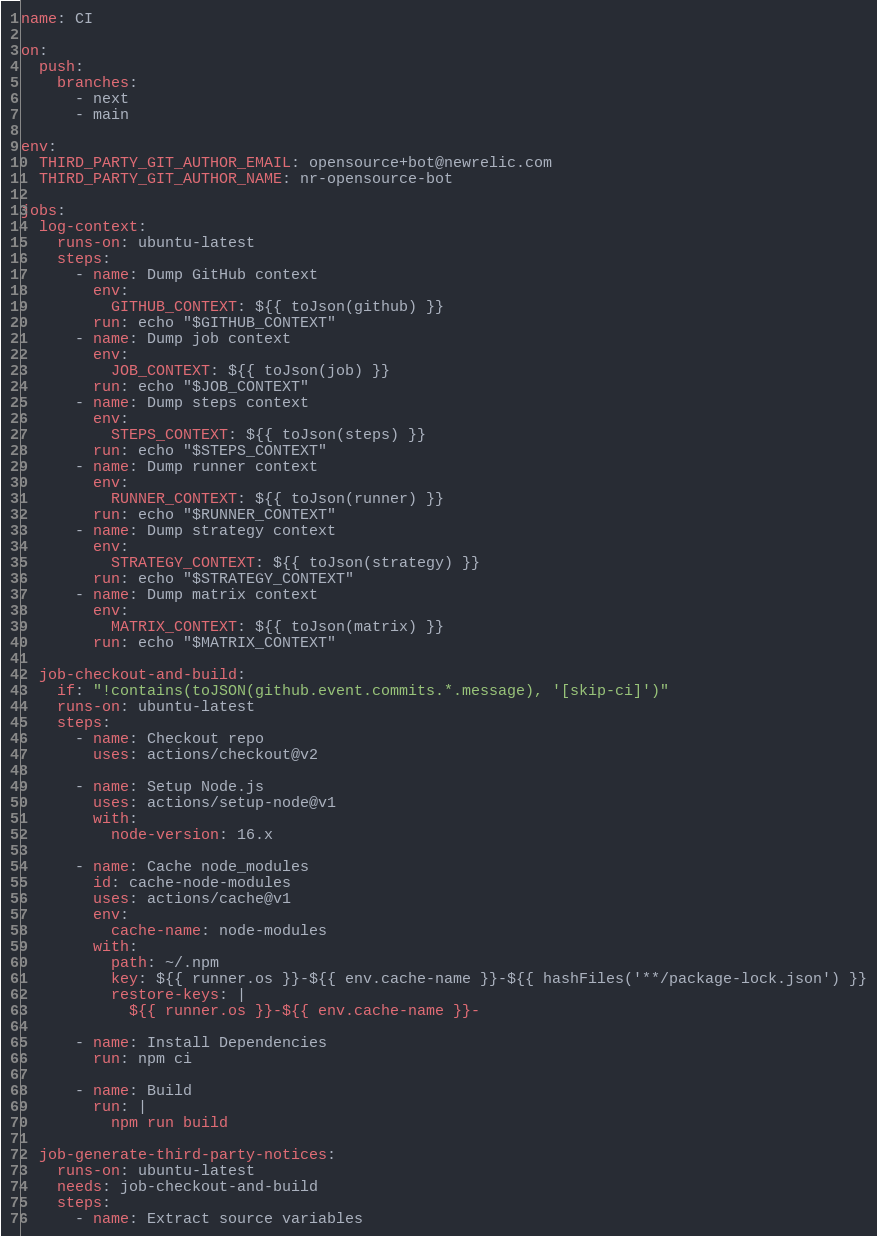<code> <loc_0><loc_0><loc_500><loc_500><_YAML_>name: CI

on:
  push:
    branches:
      - next
      - main

env:
  THIRD_PARTY_GIT_AUTHOR_EMAIL: opensource+bot@newrelic.com
  THIRD_PARTY_GIT_AUTHOR_NAME: nr-opensource-bot

jobs:
  log-context:
    runs-on: ubuntu-latest
    steps:
      - name: Dump GitHub context
        env:
          GITHUB_CONTEXT: ${{ toJson(github) }}
        run: echo "$GITHUB_CONTEXT"
      - name: Dump job context
        env:
          JOB_CONTEXT: ${{ toJson(job) }}
        run: echo "$JOB_CONTEXT"
      - name: Dump steps context
        env:
          STEPS_CONTEXT: ${{ toJson(steps) }}
        run: echo "$STEPS_CONTEXT"
      - name: Dump runner context
        env:
          RUNNER_CONTEXT: ${{ toJson(runner) }}
        run: echo "$RUNNER_CONTEXT"
      - name: Dump strategy context
        env:
          STRATEGY_CONTEXT: ${{ toJson(strategy) }}
        run: echo "$STRATEGY_CONTEXT"
      - name: Dump matrix context
        env:
          MATRIX_CONTEXT: ${{ toJson(matrix) }}
        run: echo "$MATRIX_CONTEXT"

  job-checkout-and-build:
    if: "!contains(toJSON(github.event.commits.*.message), '[skip-ci]')"
    runs-on: ubuntu-latest
    steps:
      - name: Checkout repo
        uses: actions/checkout@v2

      - name: Setup Node.js
        uses: actions/setup-node@v1
        with:
          node-version: 16.x

      - name: Cache node_modules
        id: cache-node-modules
        uses: actions/cache@v1
        env:
          cache-name: node-modules
        with:
          path: ~/.npm
          key: ${{ runner.os }}-${{ env.cache-name }}-${{ hashFiles('**/package-lock.json') }}
          restore-keys: |
            ${{ runner.os }}-${{ env.cache-name }}-

      - name: Install Dependencies
        run: npm ci

      - name: Build
        run: |
          npm run build

  job-generate-third-party-notices:
    runs-on: ubuntu-latest
    needs: job-checkout-and-build
    steps:
      - name: Extract source variables</code> 